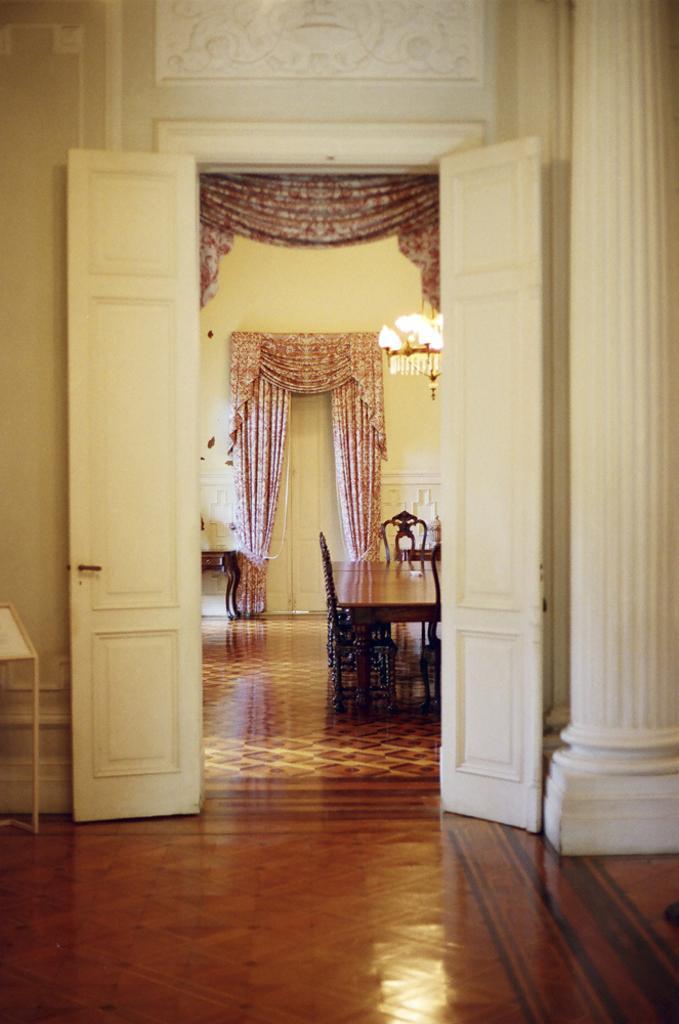Please provide a concise description of this image. In this image we can see there is an inside view of the building. And there are curtains and a wall with a design. There is a table and chairs on the floor. At the top there is a chandelier light. 